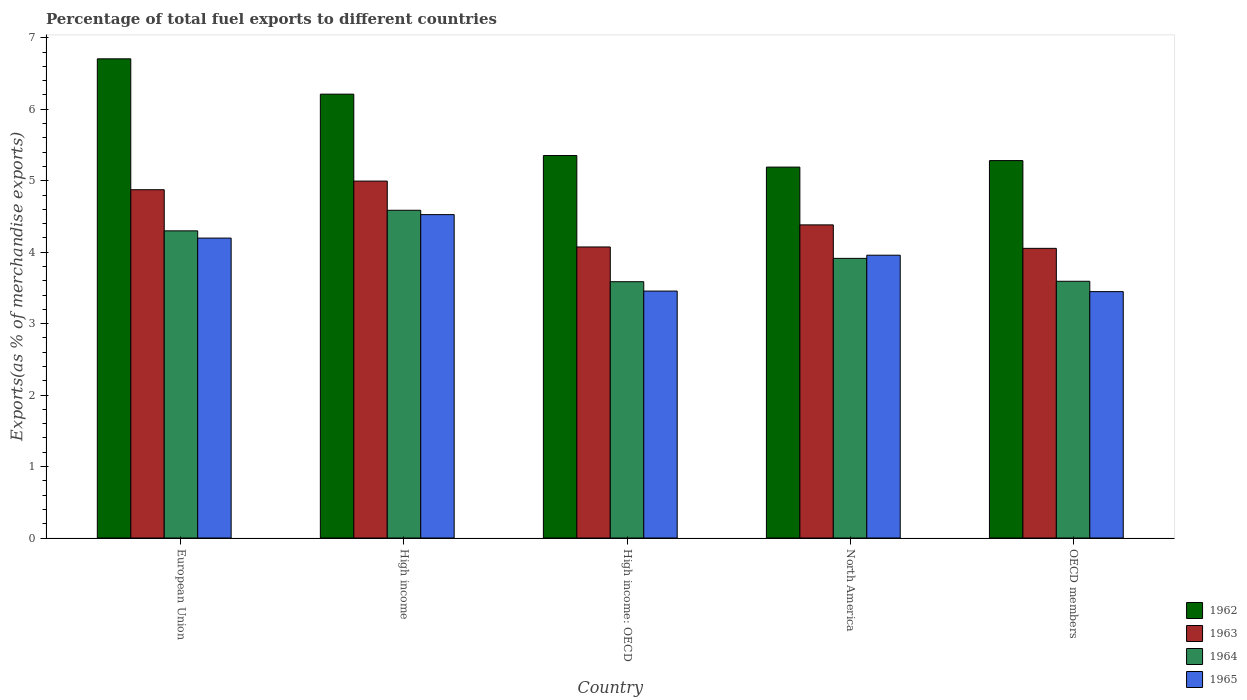How many groups of bars are there?
Your answer should be very brief. 5. Are the number of bars per tick equal to the number of legend labels?
Offer a terse response. Yes. How many bars are there on the 4th tick from the right?
Provide a succinct answer. 4. What is the label of the 4th group of bars from the left?
Make the answer very short. North America. What is the percentage of exports to different countries in 1962 in High income?
Provide a short and direct response. 6.21. Across all countries, what is the maximum percentage of exports to different countries in 1965?
Your answer should be compact. 4.53. Across all countries, what is the minimum percentage of exports to different countries in 1965?
Ensure brevity in your answer.  3.45. In which country was the percentage of exports to different countries in 1963 minimum?
Offer a terse response. OECD members. What is the total percentage of exports to different countries in 1964 in the graph?
Make the answer very short. 19.98. What is the difference between the percentage of exports to different countries in 1963 in European Union and that in High income: OECD?
Make the answer very short. 0.8. What is the difference between the percentage of exports to different countries in 1962 in European Union and the percentage of exports to different countries in 1964 in OECD members?
Ensure brevity in your answer.  3.11. What is the average percentage of exports to different countries in 1964 per country?
Make the answer very short. 4. What is the difference between the percentage of exports to different countries of/in 1963 and percentage of exports to different countries of/in 1964 in OECD members?
Keep it short and to the point. 0.46. In how many countries, is the percentage of exports to different countries in 1965 greater than 3.2 %?
Keep it short and to the point. 5. What is the ratio of the percentage of exports to different countries in 1965 in North America to that in OECD members?
Give a very brief answer. 1.15. Is the percentage of exports to different countries in 1965 in European Union less than that in High income?
Your answer should be very brief. Yes. What is the difference between the highest and the second highest percentage of exports to different countries in 1963?
Keep it short and to the point. -0.61. What is the difference between the highest and the lowest percentage of exports to different countries in 1965?
Your answer should be very brief. 1.08. In how many countries, is the percentage of exports to different countries in 1963 greater than the average percentage of exports to different countries in 1963 taken over all countries?
Give a very brief answer. 2. What does the 4th bar from the left in High income represents?
Give a very brief answer. 1965. What does the 3rd bar from the right in High income represents?
Provide a short and direct response. 1963. Is it the case that in every country, the sum of the percentage of exports to different countries in 1965 and percentage of exports to different countries in 1962 is greater than the percentage of exports to different countries in 1963?
Offer a very short reply. Yes. How many bars are there?
Your answer should be compact. 20. Are all the bars in the graph horizontal?
Your answer should be very brief. No. Are the values on the major ticks of Y-axis written in scientific E-notation?
Provide a short and direct response. No. Where does the legend appear in the graph?
Provide a succinct answer. Bottom right. How many legend labels are there?
Your answer should be compact. 4. What is the title of the graph?
Ensure brevity in your answer.  Percentage of total fuel exports to different countries. Does "1995" appear as one of the legend labels in the graph?
Offer a very short reply. No. What is the label or title of the X-axis?
Offer a terse response. Country. What is the label or title of the Y-axis?
Give a very brief answer. Exports(as % of merchandise exports). What is the Exports(as % of merchandise exports) in 1962 in European Union?
Keep it short and to the point. 6.71. What is the Exports(as % of merchandise exports) of 1963 in European Union?
Your answer should be very brief. 4.87. What is the Exports(as % of merchandise exports) of 1964 in European Union?
Ensure brevity in your answer.  4.3. What is the Exports(as % of merchandise exports) in 1965 in European Union?
Make the answer very short. 4.2. What is the Exports(as % of merchandise exports) in 1962 in High income?
Make the answer very short. 6.21. What is the Exports(as % of merchandise exports) of 1963 in High income?
Provide a short and direct response. 5. What is the Exports(as % of merchandise exports) in 1964 in High income?
Ensure brevity in your answer.  4.59. What is the Exports(as % of merchandise exports) of 1965 in High income?
Provide a succinct answer. 4.53. What is the Exports(as % of merchandise exports) of 1962 in High income: OECD?
Offer a very short reply. 5.35. What is the Exports(as % of merchandise exports) in 1963 in High income: OECD?
Give a very brief answer. 4.07. What is the Exports(as % of merchandise exports) in 1964 in High income: OECD?
Ensure brevity in your answer.  3.59. What is the Exports(as % of merchandise exports) in 1965 in High income: OECD?
Offer a terse response. 3.46. What is the Exports(as % of merchandise exports) of 1962 in North America?
Ensure brevity in your answer.  5.19. What is the Exports(as % of merchandise exports) of 1963 in North America?
Offer a very short reply. 4.38. What is the Exports(as % of merchandise exports) of 1964 in North America?
Keep it short and to the point. 3.91. What is the Exports(as % of merchandise exports) of 1965 in North America?
Your answer should be compact. 3.96. What is the Exports(as % of merchandise exports) of 1962 in OECD members?
Provide a succinct answer. 5.28. What is the Exports(as % of merchandise exports) of 1963 in OECD members?
Your answer should be very brief. 4.05. What is the Exports(as % of merchandise exports) in 1964 in OECD members?
Make the answer very short. 3.59. What is the Exports(as % of merchandise exports) of 1965 in OECD members?
Provide a succinct answer. 3.45. Across all countries, what is the maximum Exports(as % of merchandise exports) of 1962?
Ensure brevity in your answer.  6.71. Across all countries, what is the maximum Exports(as % of merchandise exports) in 1963?
Your response must be concise. 5. Across all countries, what is the maximum Exports(as % of merchandise exports) in 1964?
Keep it short and to the point. 4.59. Across all countries, what is the maximum Exports(as % of merchandise exports) of 1965?
Provide a succinct answer. 4.53. Across all countries, what is the minimum Exports(as % of merchandise exports) of 1962?
Offer a terse response. 5.19. Across all countries, what is the minimum Exports(as % of merchandise exports) of 1963?
Give a very brief answer. 4.05. Across all countries, what is the minimum Exports(as % of merchandise exports) of 1964?
Offer a terse response. 3.59. Across all countries, what is the minimum Exports(as % of merchandise exports) in 1965?
Offer a terse response. 3.45. What is the total Exports(as % of merchandise exports) in 1962 in the graph?
Provide a short and direct response. 28.74. What is the total Exports(as % of merchandise exports) in 1963 in the graph?
Provide a succinct answer. 22.38. What is the total Exports(as % of merchandise exports) in 1964 in the graph?
Ensure brevity in your answer.  19.98. What is the total Exports(as % of merchandise exports) in 1965 in the graph?
Your response must be concise. 19.58. What is the difference between the Exports(as % of merchandise exports) in 1962 in European Union and that in High income?
Offer a very short reply. 0.49. What is the difference between the Exports(as % of merchandise exports) of 1963 in European Union and that in High income?
Make the answer very short. -0.12. What is the difference between the Exports(as % of merchandise exports) in 1964 in European Union and that in High income?
Give a very brief answer. -0.29. What is the difference between the Exports(as % of merchandise exports) in 1965 in European Union and that in High income?
Provide a short and direct response. -0.33. What is the difference between the Exports(as % of merchandise exports) in 1962 in European Union and that in High income: OECD?
Your answer should be very brief. 1.35. What is the difference between the Exports(as % of merchandise exports) of 1963 in European Union and that in High income: OECD?
Keep it short and to the point. 0.8. What is the difference between the Exports(as % of merchandise exports) of 1964 in European Union and that in High income: OECD?
Provide a succinct answer. 0.71. What is the difference between the Exports(as % of merchandise exports) in 1965 in European Union and that in High income: OECD?
Provide a short and direct response. 0.74. What is the difference between the Exports(as % of merchandise exports) of 1962 in European Union and that in North America?
Provide a succinct answer. 1.52. What is the difference between the Exports(as % of merchandise exports) in 1963 in European Union and that in North America?
Your answer should be very brief. 0.49. What is the difference between the Exports(as % of merchandise exports) of 1964 in European Union and that in North America?
Provide a short and direct response. 0.39. What is the difference between the Exports(as % of merchandise exports) of 1965 in European Union and that in North America?
Your response must be concise. 0.24. What is the difference between the Exports(as % of merchandise exports) in 1962 in European Union and that in OECD members?
Provide a succinct answer. 1.42. What is the difference between the Exports(as % of merchandise exports) in 1963 in European Union and that in OECD members?
Ensure brevity in your answer.  0.82. What is the difference between the Exports(as % of merchandise exports) in 1964 in European Union and that in OECD members?
Keep it short and to the point. 0.71. What is the difference between the Exports(as % of merchandise exports) in 1965 in European Union and that in OECD members?
Ensure brevity in your answer.  0.75. What is the difference between the Exports(as % of merchandise exports) in 1962 in High income and that in High income: OECD?
Give a very brief answer. 0.86. What is the difference between the Exports(as % of merchandise exports) of 1963 in High income and that in High income: OECD?
Make the answer very short. 0.92. What is the difference between the Exports(as % of merchandise exports) in 1965 in High income and that in High income: OECD?
Keep it short and to the point. 1.07. What is the difference between the Exports(as % of merchandise exports) of 1963 in High income and that in North America?
Offer a very short reply. 0.61. What is the difference between the Exports(as % of merchandise exports) of 1964 in High income and that in North America?
Your answer should be compact. 0.67. What is the difference between the Exports(as % of merchandise exports) of 1965 in High income and that in North America?
Ensure brevity in your answer.  0.57. What is the difference between the Exports(as % of merchandise exports) of 1962 in High income and that in OECD members?
Offer a very short reply. 0.93. What is the difference between the Exports(as % of merchandise exports) of 1963 in High income and that in OECD members?
Ensure brevity in your answer.  0.94. What is the difference between the Exports(as % of merchandise exports) of 1965 in High income and that in OECD members?
Make the answer very short. 1.08. What is the difference between the Exports(as % of merchandise exports) in 1962 in High income: OECD and that in North America?
Provide a succinct answer. 0.16. What is the difference between the Exports(as % of merchandise exports) of 1963 in High income: OECD and that in North America?
Your answer should be compact. -0.31. What is the difference between the Exports(as % of merchandise exports) in 1964 in High income: OECD and that in North America?
Your response must be concise. -0.33. What is the difference between the Exports(as % of merchandise exports) in 1965 in High income: OECD and that in North America?
Provide a short and direct response. -0.5. What is the difference between the Exports(as % of merchandise exports) in 1962 in High income: OECD and that in OECD members?
Your response must be concise. 0.07. What is the difference between the Exports(as % of merchandise exports) in 1963 in High income: OECD and that in OECD members?
Offer a very short reply. 0.02. What is the difference between the Exports(as % of merchandise exports) of 1964 in High income: OECD and that in OECD members?
Keep it short and to the point. -0.01. What is the difference between the Exports(as % of merchandise exports) of 1965 in High income: OECD and that in OECD members?
Your answer should be compact. 0.01. What is the difference between the Exports(as % of merchandise exports) in 1962 in North America and that in OECD members?
Keep it short and to the point. -0.09. What is the difference between the Exports(as % of merchandise exports) of 1963 in North America and that in OECD members?
Your response must be concise. 0.33. What is the difference between the Exports(as % of merchandise exports) in 1964 in North America and that in OECD members?
Provide a short and direct response. 0.32. What is the difference between the Exports(as % of merchandise exports) of 1965 in North America and that in OECD members?
Keep it short and to the point. 0.51. What is the difference between the Exports(as % of merchandise exports) in 1962 in European Union and the Exports(as % of merchandise exports) in 1963 in High income?
Provide a succinct answer. 1.71. What is the difference between the Exports(as % of merchandise exports) in 1962 in European Union and the Exports(as % of merchandise exports) in 1964 in High income?
Offer a very short reply. 2.12. What is the difference between the Exports(as % of merchandise exports) in 1962 in European Union and the Exports(as % of merchandise exports) in 1965 in High income?
Your answer should be compact. 2.18. What is the difference between the Exports(as % of merchandise exports) in 1963 in European Union and the Exports(as % of merchandise exports) in 1964 in High income?
Provide a succinct answer. 0.29. What is the difference between the Exports(as % of merchandise exports) of 1963 in European Union and the Exports(as % of merchandise exports) of 1965 in High income?
Ensure brevity in your answer.  0.35. What is the difference between the Exports(as % of merchandise exports) in 1964 in European Union and the Exports(as % of merchandise exports) in 1965 in High income?
Give a very brief answer. -0.23. What is the difference between the Exports(as % of merchandise exports) in 1962 in European Union and the Exports(as % of merchandise exports) in 1963 in High income: OECD?
Ensure brevity in your answer.  2.63. What is the difference between the Exports(as % of merchandise exports) of 1962 in European Union and the Exports(as % of merchandise exports) of 1964 in High income: OECD?
Your answer should be very brief. 3.12. What is the difference between the Exports(as % of merchandise exports) of 1962 in European Union and the Exports(as % of merchandise exports) of 1965 in High income: OECD?
Your answer should be very brief. 3.25. What is the difference between the Exports(as % of merchandise exports) of 1963 in European Union and the Exports(as % of merchandise exports) of 1964 in High income: OECD?
Offer a terse response. 1.29. What is the difference between the Exports(as % of merchandise exports) of 1963 in European Union and the Exports(as % of merchandise exports) of 1965 in High income: OECD?
Your response must be concise. 1.42. What is the difference between the Exports(as % of merchandise exports) in 1964 in European Union and the Exports(as % of merchandise exports) in 1965 in High income: OECD?
Offer a very short reply. 0.84. What is the difference between the Exports(as % of merchandise exports) of 1962 in European Union and the Exports(as % of merchandise exports) of 1963 in North America?
Your answer should be very brief. 2.32. What is the difference between the Exports(as % of merchandise exports) in 1962 in European Union and the Exports(as % of merchandise exports) in 1964 in North America?
Ensure brevity in your answer.  2.79. What is the difference between the Exports(as % of merchandise exports) of 1962 in European Union and the Exports(as % of merchandise exports) of 1965 in North America?
Offer a terse response. 2.75. What is the difference between the Exports(as % of merchandise exports) in 1963 in European Union and the Exports(as % of merchandise exports) in 1964 in North America?
Provide a short and direct response. 0.96. What is the difference between the Exports(as % of merchandise exports) of 1963 in European Union and the Exports(as % of merchandise exports) of 1965 in North America?
Give a very brief answer. 0.92. What is the difference between the Exports(as % of merchandise exports) in 1964 in European Union and the Exports(as % of merchandise exports) in 1965 in North America?
Your answer should be very brief. 0.34. What is the difference between the Exports(as % of merchandise exports) in 1962 in European Union and the Exports(as % of merchandise exports) in 1963 in OECD members?
Offer a terse response. 2.65. What is the difference between the Exports(as % of merchandise exports) of 1962 in European Union and the Exports(as % of merchandise exports) of 1964 in OECD members?
Give a very brief answer. 3.11. What is the difference between the Exports(as % of merchandise exports) in 1962 in European Union and the Exports(as % of merchandise exports) in 1965 in OECD members?
Make the answer very short. 3.26. What is the difference between the Exports(as % of merchandise exports) of 1963 in European Union and the Exports(as % of merchandise exports) of 1964 in OECD members?
Your response must be concise. 1.28. What is the difference between the Exports(as % of merchandise exports) of 1963 in European Union and the Exports(as % of merchandise exports) of 1965 in OECD members?
Ensure brevity in your answer.  1.43. What is the difference between the Exports(as % of merchandise exports) of 1964 in European Union and the Exports(as % of merchandise exports) of 1965 in OECD members?
Offer a terse response. 0.85. What is the difference between the Exports(as % of merchandise exports) in 1962 in High income and the Exports(as % of merchandise exports) in 1963 in High income: OECD?
Provide a short and direct response. 2.14. What is the difference between the Exports(as % of merchandise exports) of 1962 in High income and the Exports(as % of merchandise exports) of 1964 in High income: OECD?
Your answer should be compact. 2.62. What is the difference between the Exports(as % of merchandise exports) in 1962 in High income and the Exports(as % of merchandise exports) in 1965 in High income: OECD?
Your response must be concise. 2.76. What is the difference between the Exports(as % of merchandise exports) in 1963 in High income and the Exports(as % of merchandise exports) in 1964 in High income: OECD?
Your answer should be very brief. 1.41. What is the difference between the Exports(as % of merchandise exports) in 1963 in High income and the Exports(as % of merchandise exports) in 1965 in High income: OECD?
Provide a succinct answer. 1.54. What is the difference between the Exports(as % of merchandise exports) in 1964 in High income and the Exports(as % of merchandise exports) in 1965 in High income: OECD?
Provide a succinct answer. 1.13. What is the difference between the Exports(as % of merchandise exports) in 1962 in High income and the Exports(as % of merchandise exports) in 1963 in North America?
Give a very brief answer. 1.83. What is the difference between the Exports(as % of merchandise exports) in 1962 in High income and the Exports(as % of merchandise exports) in 1964 in North America?
Provide a short and direct response. 2.3. What is the difference between the Exports(as % of merchandise exports) of 1962 in High income and the Exports(as % of merchandise exports) of 1965 in North America?
Ensure brevity in your answer.  2.25. What is the difference between the Exports(as % of merchandise exports) in 1963 in High income and the Exports(as % of merchandise exports) in 1964 in North America?
Ensure brevity in your answer.  1.08. What is the difference between the Exports(as % of merchandise exports) of 1963 in High income and the Exports(as % of merchandise exports) of 1965 in North America?
Provide a short and direct response. 1.04. What is the difference between the Exports(as % of merchandise exports) of 1964 in High income and the Exports(as % of merchandise exports) of 1965 in North America?
Your answer should be compact. 0.63. What is the difference between the Exports(as % of merchandise exports) in 1962 in High income and the Exports(as % of merchandise exports) in 1963 in OECD members?
Provide a short and direct response. 2.16. What is the difference between the Exports(as % of merchandise exports) of 1962 in High income and the Exports(as % of merchandise exports) of 1964 in OECD members?
Your answer should be compact. 2.62. What is the difference between the Exports(as % of merchandise exports) of 1962 in High income and the Exports(as % of merchandise exports) of 1965 in OECD members?
Your answer should be very brief. 2.76. What is the difference between the Exports(as % of merchandise exports) in 1963 in High income and the Exports(as % of merchandise exports) in 1964 in OECD members?
Provide a short and direct response. 1.4. What is the difference between the Exports(as % of merchandise exports) in 1963 in High income and the Exports(as % of merchandise exports) in 1965 in OECD members?
Provide a succinct answer. 1.55. What is the difference between the Exports(as % of merchandise exports) of 1964 in High income and the Exports(as % of merchandise exports) of 1965 in OECD members?
Your answer should be compact. 1.14. What is the difference between the Exports(as % of merchandise exports) in 1962 in High income: OECD and the Exports(as % of merchandise exports) in 1963 in North America?
Give a very brief answer. 0.97. What is the difference between the Exports(as % of merchandise exports) of 1962 in High income: OECD and the Exports(as % of merchandise exports) of 1964 in North America?
Keep it short and to the point. 1.44. What is the difference between the Exports(as % of merchandise exports) of 1962 in High income: OECD and the Exports(as % of merchandise exports) of 1965 in North America?
Offer a terse response. 1.39. What is the difference between the Exports(as % of merchandise exports) in 1963 in High income: OECD and the Exports(as % of merchandise exports) in 1964 in North America?
Offer a very short reply. 0.16. What is the difference between the Exports(as % of merchandise exports) of 1963 in High income: OECD and the Exports(as % of merchandise exports) of 1965 in North America?
Provide a succinct answer. 0.12. What is the difference between the Exports(as % of merchandise exports) in 1964 in High income: OECD and the Exports(as % of merchandise exports) in 1965 in North America?
Provide a short and direct response. -0.37. What is the difference between the Exports(as % of merchandise exports) of 1962 in High income: OECD and the Exports(as % of merchandise exports) of 1963 in OECD members?
Offer a very short reply. 1.3. What is the difference between the Exports(as % of merchandise exports) of 1962 in High income: OECD and the Exports(as % of merchandise exports) of 1964 in OECD members?
Provide a succinct answer. 1.76. What is the difference between the Exports(as % of merchandise exports) in 1962 in High income: OECD and the Exports(as % of merchandise exports) in 1965 in OECD members?
Your answer should be compact. 1.9. What is the difference between the Exports(as % of merchandise exports) in 1963 in High income: OECD and the Exports(as % of merchandise exports) in 1964 in OECD members?
Your answer should be compact. 0.48. What is the difference between the Exports(as % of merchandise exports) of 1963 in High income: OECD and the Exports(as % of merchandise exports) of 1965 in OECD members?
Your answer should be very brief. 0.62. What is the difference between the Exports(as % of merchandise exports) in 1964 in High income: OECD and the Exports(as % of merchandise exports) in 1965 in OECD members?
Your answer should be compact. 0.14. What is the difference between the Exports(as % of merchandise exports) in 1962 in North America and the Exports(as % of merchandise exports) in 1963 in OECD members?
Offer a very short reply. 1.14. What is the difference between the Exports(as % of merchandise exports) in 1962 in North America and the Exports(as % of merchandise exports) in 1964 in OECD members?
Offer a terse response. 1.6. What is the difference between the Exports(as % of merchandise exports) of 1962 in North America and the Exports(as % of merchandise exports) of 1965 in OECD members?
Ensure brevity in your answer.  1.74. What is the difference between the Exports(as % of merchandise exports) of 1963 in North America and the Exports(as % of merchandise exports) of 1964 in OECD members?
Your response must be concise. 0.79. What is the difference between the Exports(as % of merchandise exports) in 1963 in North America and the Exports(as % of merchandise exports) in 1965 in OECD members?
Ensure brevity in your answer.  0.93. What is the difference between the Exports(as % of merchandise exports) in 1964 in North America and the Exports(as % of merchandise exports) in 1965 in OECD members?
Your answer should be compact. 0.47. What is the average Exports(as % of merchandise exports) of 1962 per country?
Keep it short and to the point. 5.75. What is the average Exports(as % of merchandise exports) of 1963 per country?
Provide a succinct answer. 4.48. What is the average Exports(as % of merchandise exports) of 1964 per country?
Provide a short and direct response. 4. What is the average Exports(as % of merchandise exports) in 1965 per country?
Offer a terse response. 3.92. What is the difference between the Exports(as % of merchandise exports) of 1962 and Exports(as % of merchandise exports) of 1963 in European Union?
Provide a succinct answer. 1.83. What is the difference between the Exports(as % of merchandise exports) in 1962 and Exports(as % of merchandise exports) in 1964 in European Union?
Your answer should be very brief. 2.41. What is the difference between the Exports(as % of merchandise exports) of 1962 and Exports(as % of merchandise exports) of 1965 in European Union?
Keep it short and to the point. 2.51. What is the difference between the Exports(as % of merchandise exports) in 1963 and Exports(as % of merchandise exports) in 1964 in European Union?
Make the answer very short. 0.58. What is the difference between the Exports(as % of merchandise exports) of 1963 and Exports(as % of merchandise exports) of 1965 in European Union?
Your response must be concise. 0.68. What is the difference between the Exports(as % of merchandise exports) in 1964 and Exports(as % of merchandise exports) in 1965 in European Union?
Provide a succinct answer. 0.1. What is the difference between the Exports(as % of merchandise exports) of 1962 and Exports(as % of merchandise exports) of 1963 in High income?
Your answer should be compact. 1.22. What is the difference between the Exports(as % of merchandise exports) of 1962 and Exports(as % of merchandise exports) of 1964 in High income?
Offer a terse response. 1.63. What is the difference between the Exports(as % of merchandise exports) of 1962 and Exports(as % of merchandise exports) of 1965 in High income?
Your answer should be compact. 1.69. What is the difference between the Exports(as % of merchandise exports) in 1963 and Exports(as % of merchandise exports) in 1964 in High income?
Your answer should be compact. 0.41. What is the difference between the Exports(as % of merchandise exports) of 1963 and Exports(as % of merchandise exports) of 1965 in High income?
Make the answer very short. 0.47. What is the difference between the Exports(as % of merchandise exports) of 1964 and Exports(as % of merchandise exports) of 1965 in High income?
Your response must be concise. 0.06. What is the difference between the Exports(as % of merchandise exports) of 1962 and Exports(as % of merchandise exports) of 1963 in High income: OECD?
Offer a terse response. 1.28. What is the difference between the Exports(as % of merchandise exports) of 1962 and Exports(as % of merchandise exports) of 1964 in High income: OECD?
Provide a succinct answer. 1.77. What is the difference between the Exports(as % of merchandise exports) of 1962 and Exports(as % of merchandise exports) of 1965 in High income: OECD?
Your answer should be compact. 1.9. What is the difference between the Exports(as % of merchandise exports) in 1963 and Exports(as % of merchandise exports) in 1964 in High income: OECD?
Provide a succinct answer. 0.49. What is the difference between the Exports(as % of merchandise exports) of 1963 and Exports(as % of merchandise exports) of 1965 in High income: OECD?
Your answer should be very brief. 0.62. What is the difference between the Exports(as % of merchandise exports) of 1964 and Exports(as % of merchandise exports) of 1965 in High income: OECD?
Your answer should be very brief. 0.13. What is the difference between the Exports(as % of merchandise exports) of 1962 and Exports(as % of merchandise exports) of 1963 in North America?
Make the answer very short. 0.81. What is the difference between the Exports(as % of merchandise exports) of 1962 and Exports(as % of merchandise exports) of 1964 in North America?
Keep it short and to the point. 1.28. What is the difference between the Exports(as % of merchandise exports) of 1962 and Exports(as % of merchandise exports) of 1965 in North America?
Ensure brevity in your answer.  1.23. What is the difference between the Exports(as % of merchandise exports) in 1963 and Exports(as % of merchandise exports) in 1964 in North America?
Offer a very short reply. 0.47. What is the difference between the Exports(as % of merchandise exports) in 1963 and Exports(as % of merchandise exports) in 1965 in North America?
Your response must be concise. 0.42. What is the difference between the Exports(as % of merchandise exports) of 1964 and Exports(as % of merchandise exports) of 1965 in North America?
Ensure brevity in your answer.  -0.04. What is the difference between the Exports(as % of merchandise exports) of 1962 and Exports(as % of merchandise exports) of 1963 in OECD members?
Provide a short and direct response. 1.23. What is the difference between the Exports(as % of merchandise exports) in 1962 and Exports(as % of merchandise exports) in 1964 in OECD members?
Your answer should be very brief. 1.69. What is the difference between the Exports(as % of merchandise exports) of 1962 and Exports(as % of merchandise exports) of 1965 in OECD members?
Ensure brevity in your answer.  1.83. What is the difference between the Exports(as % of merchandise exports) of 1963 and Exports(as % of merchandise exports) of 1964 in OECD members?
Your answer should be compact. 0.46. What is the difference between the Exports(as % of merchandise exports) in 1963 and Exports(as % of merchandise exports) in 1965 in OECD members?
Give a very brief answer. 0.61. What is the difference between the Exports(as % of merchandise exports) in 1964 and Exports(as % of merchandise exports) in 1965 in OECD members?
Your response must be concise. 0.14. What is the ratio of the Exports(as % of merchandise exports) of 1962 in European Union to that in High income?
Make the answer very short. 1.08. What is the ratio of the Exports(as % of merchandise exports) in 1963 in European Union to that in High income?
Keep it short and to the point. 0.98. What is the ratio of the Exports(as % of merchandise exports) of 1964 in European Union to that in High income?
Your answer should be very brief. 0.94. What is the ratio of the Exports(as % of merchandise exports) of 1965 in European Union to that in High income?
Ensure brevity in your answer.  0.93. What is the ratio of the Exports(as % of merchandise exports) of 1962 in European Union to that in High income: OECD?
Provide a short and direct response. 1.25. What is the ratio of the Exports(as % of merchandise exports) of 1963 in European Union to that in High income: OECD?
Keep it short and to the point. 1.2. What is the ratio of the Exports(as % of merchandise exports) of 1964 in European Union to that in High income: OECD?
Keep it short and to the point. 1.2. What is the ratio of the Exports(as % of merchandise exports) of 1965 in European Union to that in High income: OECD?
Make the answer very short. 1.21. What is the ratio of the Exports(as % of merchandise exports) in 1962 in European Union to that in North America?
Keep it short and to the point. 1.29. What is the ratio of the Exports(as % of merchandise exports) of 1963 in European Union to that in North America?
Offer a very short reply. 1.11. What is the ratio of the Exports(as % of merchandise exports) in 1964 in European Union to that in North America?
Ensure brevity in your answer.  1.1. What is the ratio of the Exports(as % of merchandise exports) in 1965 in European Union to that in North America?
Give a very brief answer. 1.06. What is the ratio of the Exports(as % of merchandise exports) of 1962 in European Union to that in OECD members?
Offer a very short reply. 1.27. What is the ratio of the Exports(as % of merchandise exports) in 1963 in European Union to that in OECD members?
Your answer should be compact. 1.2. What is the ratio of the Exports(as % of merchandise exports) of 1964 in European Union to that in OECD members?
Ensure brevity in your answer.  1.2. What is the ratio of the Exports(as % of merchandise exports) of 1965 in European Union to that in OECD members?
Offer a terse response. 1.22. What is the ratio of the Exports(as % of merchandise exports) in 1962 in High income to that in High income: OECD?
Provide a succinct answer. 1.16. What is the ratio of the Exports(as % of merchandise exports) of 1963 in High income to that in High income: OECD?
Ensure brevity in your answer.  1.23. What is the ratio of the Exports(as % of merchandise exports) in 1964 in High income to that in High income: OECD?
Offer a very short reply. 1.28. What is the ratio of the Exports(as % of merchandise exports) in 1965 in High income to that in High income: OECD?
Give a very brief answer. 1.31. What is the ratio of the Exports(as % of merchandise exports) in 1962 in High income to that in North America?
Give a very brief answer. 1.2. What is the ratio of the Exports(as % of merchandise exports) of 1963 in High income to that in North America?
Offer a very short reply. 1.14. What is the ratio of the Exports(as % of merchandise exports) in 1964 in High income to that in North America?
Ensure brevity in your answer.  1.17. What is the ratio of the Exports(as % of merchandise exports) of 1965 in High income to that in North America?
Your answer should be very brief. 1.14. What is the ratio of the Exports(as % of merchandise exports) of 1962 in High income to that in OECD members?
Provide a short and direct response. 1.18. What is the ratio of the Exports(as % of merchandise exports) of 1963 in High income to that in OECD members?
Make the answer very short. 1.23. What is the ratio of the Exports(as % of merchandise exports) in 1964 in High income to that in OECD members?
Make the answer very short. 1.28. What is the ratio of the Exports(as % of merchandise exports) of 1965 in High income to that in OECD members?
Provide a succinct answer. 1.31. What is the ratio of the Exports(as % of merchandise exports) in 1962 in High income: OECD to that in North America?
Keep it short and to the point. 1.03. What is the ratio of the Exports(as % of merchandise exports) in 1963 in High income: OECD to that in North America?
Your answer should be compact. 0.93. What is the ratio of the Exports(as % of merchandise exports) of 1964 in High income: OECD to that in North America?
Give a very brief answer. 0.92. What is the ratio of the Exports(as % of merchandise exports) in 1965 in High income: OECD to that in North America?
Provide a short and direct response. 0.87. What is the ratio of the Exports(as % of merchandise exports) of 1962 in High income: OECD to that in OECD members?
Give a very brief answer. 1.01. What is the ratio of the Exports(as % of merchandise exports) in 1965 in High income: OECD to that in OECD members?
Offer a terse response. 1. What is the ratio of the Exports(as % of merchandise exports) in 1962 in North America to that in OECD members?
Offer a terse response. 0.98. What is the ratio of the Exports(as % of merchandise exports) in 1963 in North America to that in OECD members?
Offer a very short reply. 1.08. What is the ratio of the Exports(as % of merchandise exports) in 1964 in North America to that in OECD members?
Your answer should be compact. 1.09. What is the ratio of the Exports(as % of merchandise exports) in 1965 in North America to that in OECD members?
Keep it short and to the point. 1.15. What is the difference between the highest and the second highest Exports(as % of merchandise exports) in 1962?
Provide a succinct answer. 0.49. What is the difference between the highest and the second highest Exports(as % of merchandise exports) of 1963?
Ensure brevity in your answer.  0.12. What is the difference between the highest and the second highest Exports(as % of merchandise exports) in 1964?
Ensure brevity in your answer.  0.29. What is the difference between the highest and the second highest Exports(as % of merchandise exports) of 1965?
Provide a succinct answer. 0.33. What is the difference between the highest and the lowest Exports(as % of merchandise exports) of 1962?
Give a very brief answer. 1.52. What is the difference between the highest and the lowest Exports(as % of merchandise exports) in 1963?
Offer a terse response. 0.94. What is the difference between the highest and the lowest Exports(as % of merchandise exports) of 1964?
Make the answer very short. 1. What is the difference between the highest and the lowest Exports(as % of merchandise exports) of 1965?
Provide a short and direct response. 1.08. 